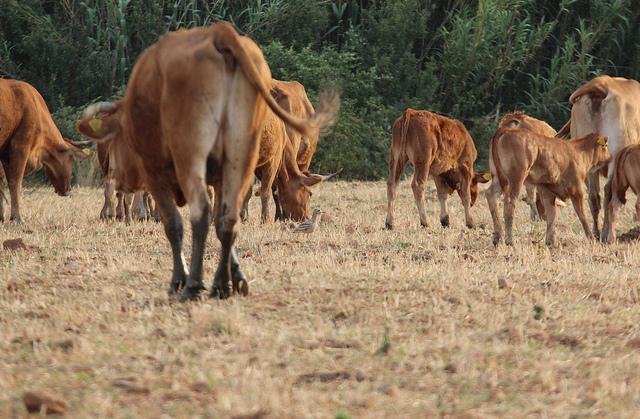How many cows can be seen?
Give a very brief answer. 8. 